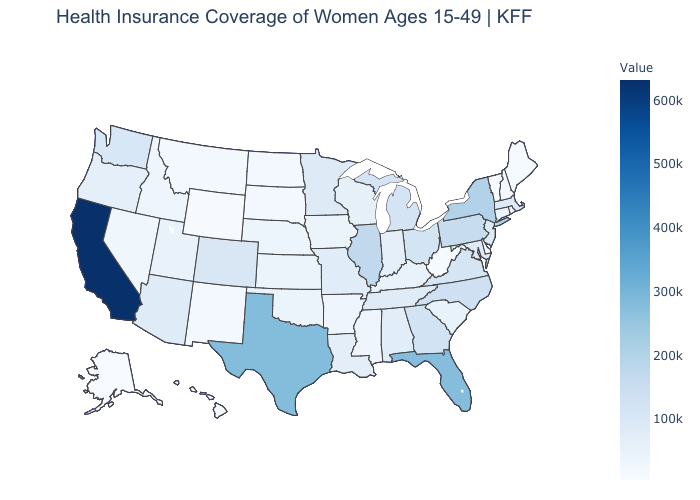Among the states that border Massachusetts , which have the lowest value?
Be succinct. Vermont. Among the states that border Nebraska , does Colorado have the highest value?
Be succinct. Yes. Is the legend a continuous bar?
Give a very brief answer. Yes. Which states have the lowest value in the MidWest?
Write a very short answer. South Dakota. 